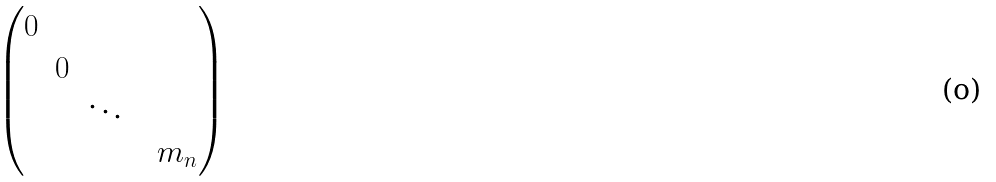Convert formula to latex. <formula><loc_0><loc_0><loc_500><loc_500>\begin{pmatrix} 0 & & & & \\ & 0 & & & \\ & & \ddots & & \\ & & & & m _ { n } \end{pmatrix}</formula> 